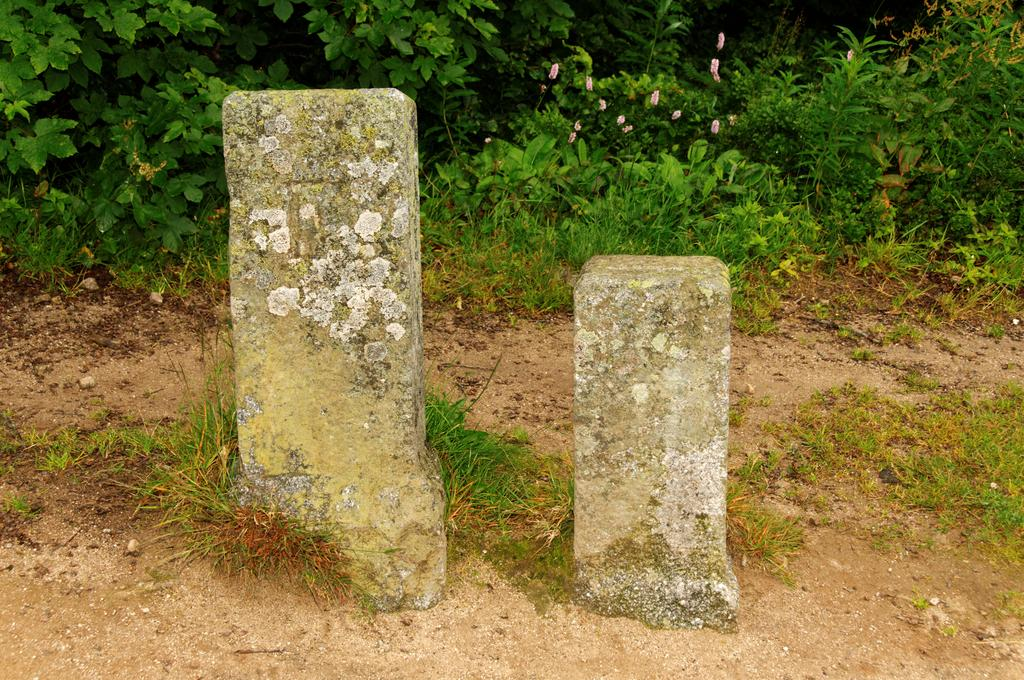How many pillars can be seen in the image? There are two pillars in the image. Where are the pillars located? The pillars are on the land in the image. What type of vegetation is present in the image? There is grass and plants in the image. Are there any flowers visible in the image? Yes, there are flowers associated with the plants in the image. What type of plastic is covering the tank in the image? There is no plastic or tank present in the image. Can you describe the fan that is spinning in the image? There is no fan present in the image. 